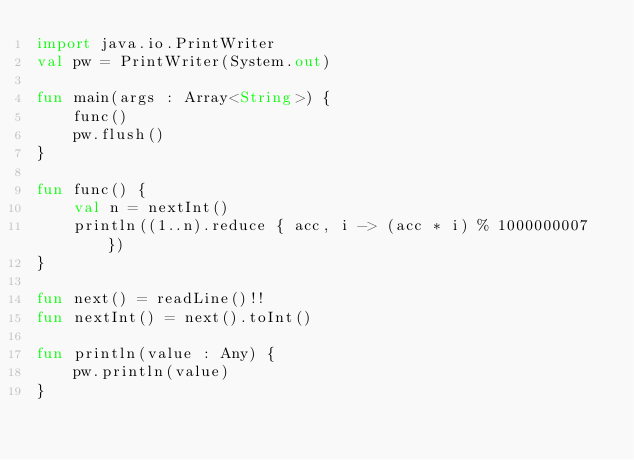Convert code to text. <code><loc_0><loc_0><loc_500><loc_500><_Kotlin_>import java.io.PrintWriter
val pw = PrintWriter(System.out)

fun main(args : Array<String>) {
    func()
    pw.flush()
}

fun func() {
    val n = nextInt()
    println((1..n).reduce { acc, i -> (acc * i) % 1000000007 })
}

fun next() = readLine()!!
fun nextInt() = next().toInt()

fun println(value : Any) {
    pw.println(value)
}</code> 